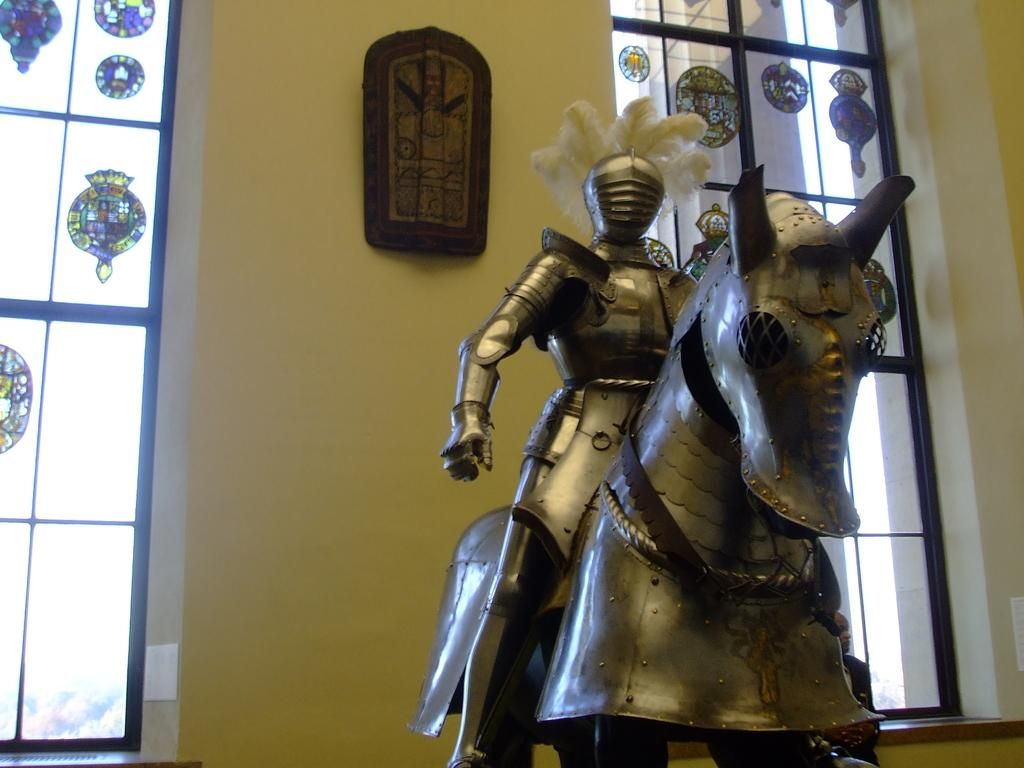What is the main object in the image? There is an armor in the image. What can be seen in the background of the image? There are windows and a wall in the background of the image. What type of berry is hanging from the armor in the image? There is no berry present in the image; it features an armor and a background with windows and a wall. 